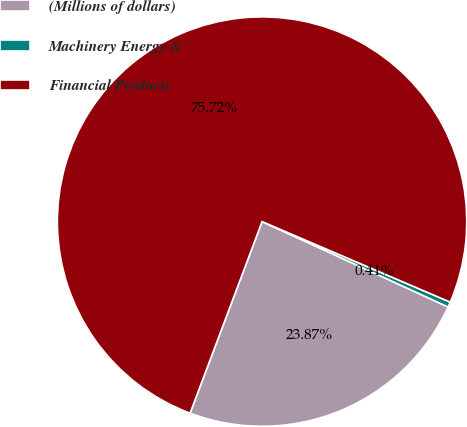<chart> <loc_0><loc_0><loc_500><loc_500><pie_chart><fcel>(Millions of dollars)<fcel>Machinery Energy &<fcel>Financial Products<nl><fcel>23.87%<fcel>0.41%<fcel>75.71%<nl></chart> 